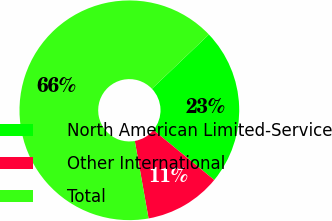<chart> <loc_0><loc_0><loc_500><loc_500><pie_chart><fcel>North American Limited-Service<fcel>Other International<fcel>Total<nl><fcel>23.06%<fcel>11.26%<fcel>65.68%<nl></chart> 